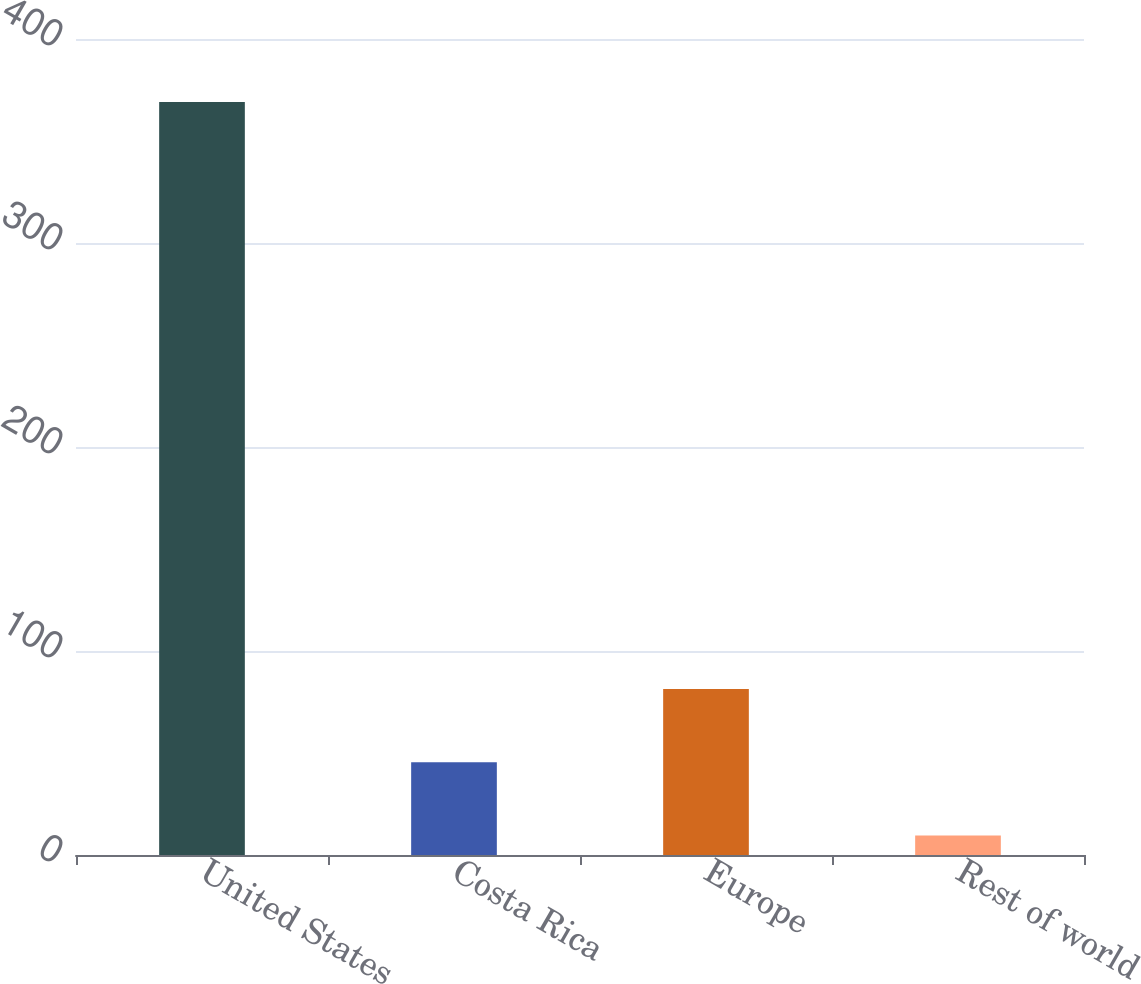Convert chart. <chart><loc_0><loc_0><loc_500><loc_500><bar_chart><fcel>United States<fcel>Costa Rica<fcel>Europe<fcel>Rest of world<nl><fcel>369.1<fcel>45.46<fcel>81.42<fcel>9.5<nl></chart> 